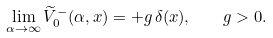Convert formula to latex. <formula><loc_0><loc_0><loc_500><loc_500>\lim _ { \alpha \to \infty } { \widetilde { V } } ^ { - } _ { 0 } ( \alpha , x ) = + g \, \delta ( x ) , \quad g > 0 .</formula> 